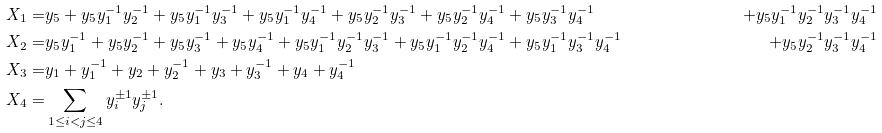<formula> <loc_0><loc_0><loc_500><loc_500>X _ { 1 } = & y _ { 5 } + y _ { 5 } y _ { 1 } ^ { - 1 } y _ { 2 } ^ { - 1 } + y _ { 5 } y _ { 1 } ^ { - 1 } y _ { 3 } ^ { - 1 } + y _ { 5 } y _ { 1 } ^ { - 1 } y _ { 4 } ^ { - 1 } + y _ { 5 } y _ { 2 } ^ { - 1 } y _ { 3 } ^ { - 1 } + y _ { 5 } y _ { 2 } ^ { - 1 } y _ { 4 } ^ { - 1 } + y _ { 5 } y _ { 3 } ^ { - 1 } y _ { 4 } ^ { - 1 } & + y _ { 5 } y _ { 1 } ^ { - 1 } y _ { 2 } ^ { - 1 } y _ { 3 } ^ { - 1 } y _ { 4 } ^ { - 1 } \\ X _ { 2 } = & y _ { 5 } y _ { 1 } ^ { - 1 } + y _ { 5 } y _ { 2 } ^ { - 1 } + y _ { 5 } y _ { 3 } ^ { - 1 } + y _ { 5 } y _ { 4 } ^ { - 1 } + y _ { 5 } y _ { 1 } ^ { - 1 } y _ { 2 } ^ { - 1 } y _ { 3 } ^ { - 1 } + y _ { 5 } y _ { 1 } ^ { - 1 } y _ { 2 } ^ { - 1 } y _ { 4 } ^ { - 1 } + y _ { 5 } y _ { 1 } ^ { - 1 } y _ { 3 } ^ { - 1 } y _ { 4 } ^ { - 1 } & + y _ { 5 } y _ { 2 } ^ { - 1 } y _ { 3 } ^ { - 1 } y _ { 4 } ^ { - 1 } \\ X _ { 3 } = & y _ { 1 } + y _ { 1 } ^ { - 1 } + y _ { 2 } + y _ { 2 } ^ { - 1 } + y _ { 3 } + y _ { 3 } ^ { - 1 } + y _ { 4 } + y _ { 4 } ^ { - 1 } \\ X _ { 4 } = & \sum _ { 1 \leq i < j \leq 4 } y _ { i } ^ { \pm 1 } y _ { j } ^ { \pm 1 } .</formula> 